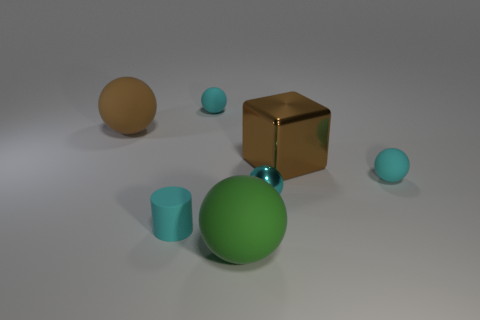Subtract all cyan blocks. How many cyan spheres are left? 3 Subtract all gray balls. Subtract all gray blocks. How many balls are left? 5 Add 3 large cubes. How many objects exist? 10 Subtract all cylinders. How many objects are left? 6 Subtract all small cyan matte things. Subtract all tiny matte objects. How many objects are left? 1 Add 5 large brown rubber balls. How many large brown rubber balls are left? 6 Add 3 big cubes. How many big cubes exist? 4 Subtract 0 yellow spheres. How many objects are left? 7 